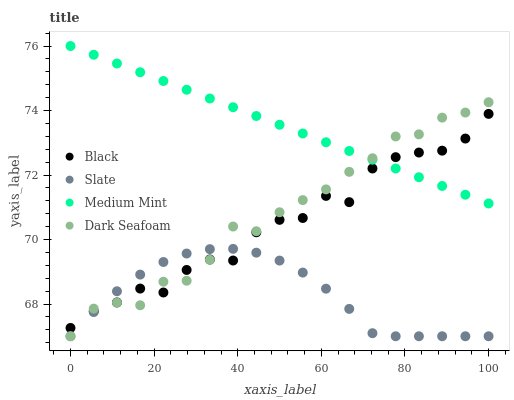Does Slate have the minimum area under the curve?
Answer yes or no. Yes. Does Medium Mint have the maximum area under the curve?
Answer yes or no. Yes. Does Black have the minimum area under the curve?
Answer yes or no. No. Does Black have the maximum area under the curve?
Answer yes or no. No. Is Medium Mint the smoothest?
Answer yes or no. Yes. Is Black the roughest?
Answer yes or no. Yes. Is Slate the smoothest?
Answer yes or no. No. Is Slate the roughest?
Answer yes or no. No. Does Slate have the lowest value?
Answer yes or no. Yes. Does Black have the lowest value?
Answer yes or no. No. Does Medium Mint have the highest value?
Answer yes or no. Yes. Does Black have the highest value?
Answer yes or no. No. Is Slate less than Medium Mint?
Answer yes or no. Yes. Is Medium Mint greater than Slate?
Answer yes or no. Yes. Does Black intersect Slate?
Answer yes or no. Yes. Is Black less than Slate?
Answer yes or no. No. Is Black greater than Slate?
Answer yes or no. No. Does Slate intersect Medium Mint?
Answer yes or no. No. 